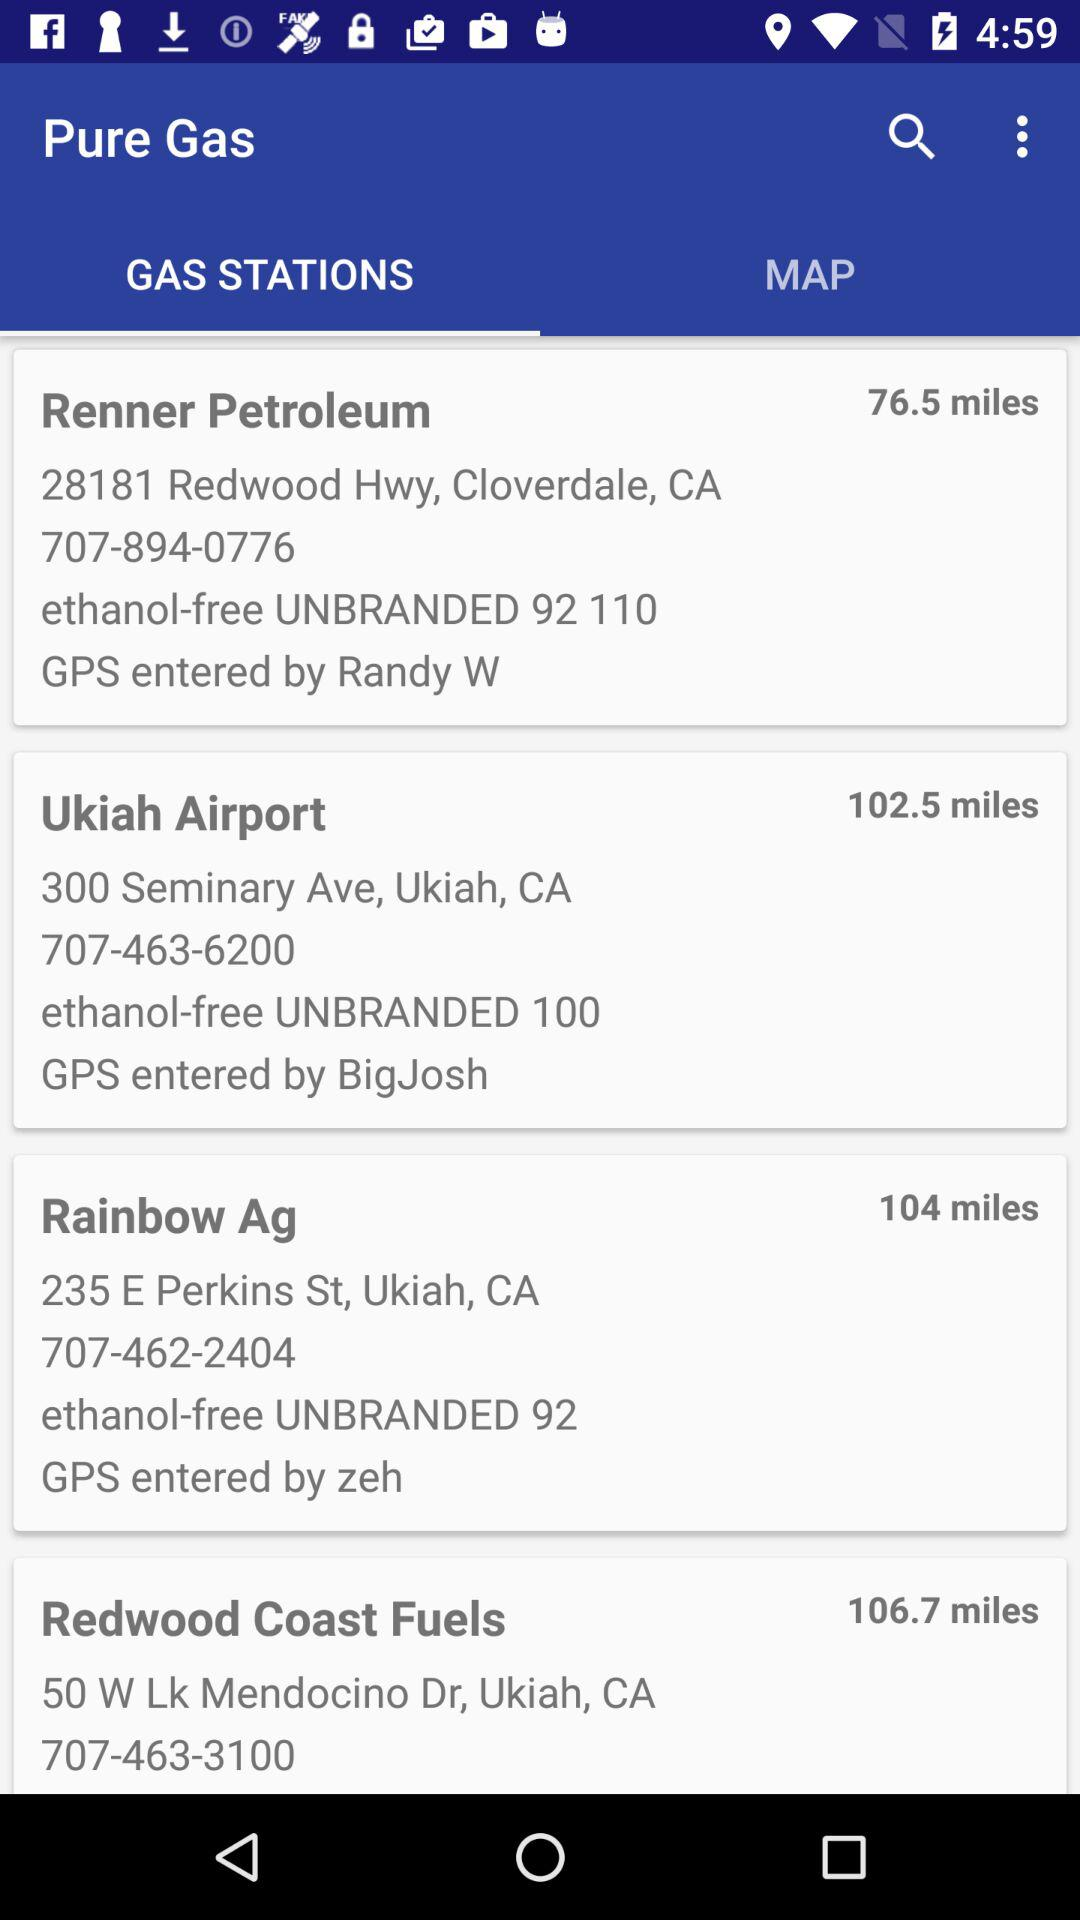How far is the Ukiah Airport? The Ukiah Airport is 102.5 miles far. 